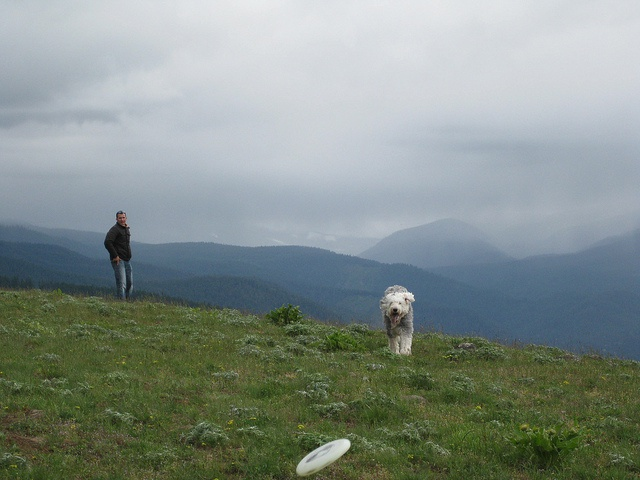Describe the objects in this image and their specific colors. I can see dog in lightgray, gray, darkgray, and black tones, people in lightgray, black, gray, blue, and darkblue tones, and frisbee in lightgray, darkgray, and gray tones in this image. 